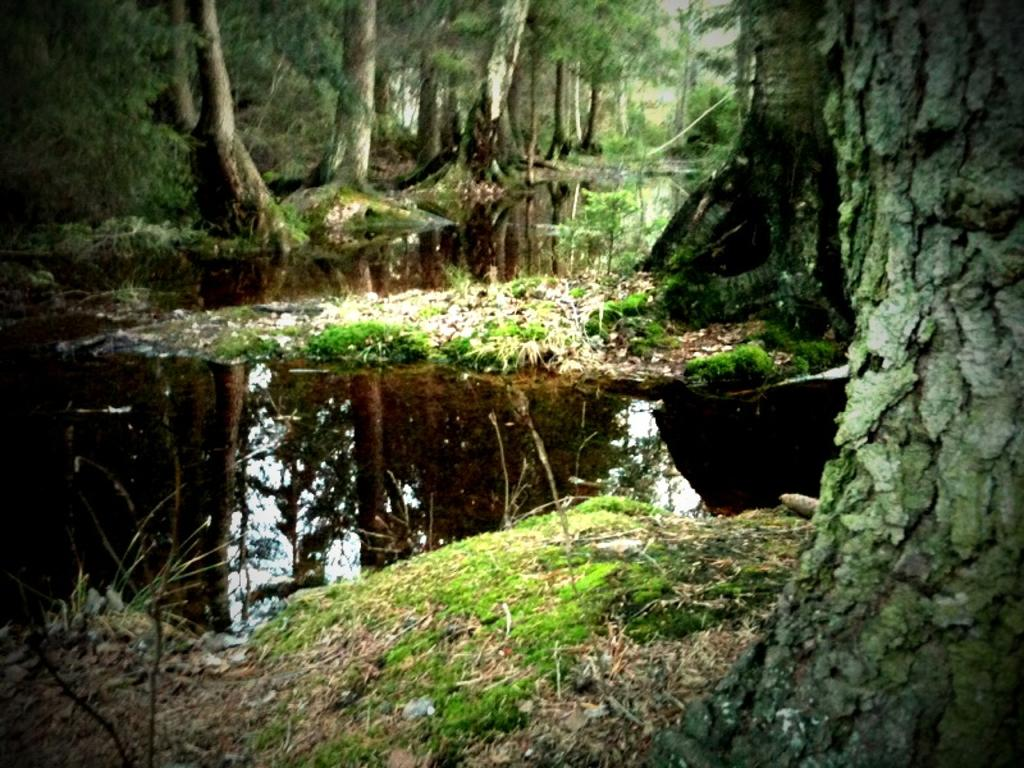What is located at the bottom of the image? There is a small pond at the bottom of the image. What type of vegetation is present at the bottom of the image? Grass and trees are visible at the bottom of the image. What can be seen in the background of the image? There is a group of trees in the background of the image. Can you see the sun setting behind the trees in the image? The provided facts do not mention the sun or its position in the image, so we cannot determine if it is visible or setting behind the trees. Is there an owl perched on one of the branches in the image? There is no mention of an owl or any animals in the image, so we cannot confirm its presence. 